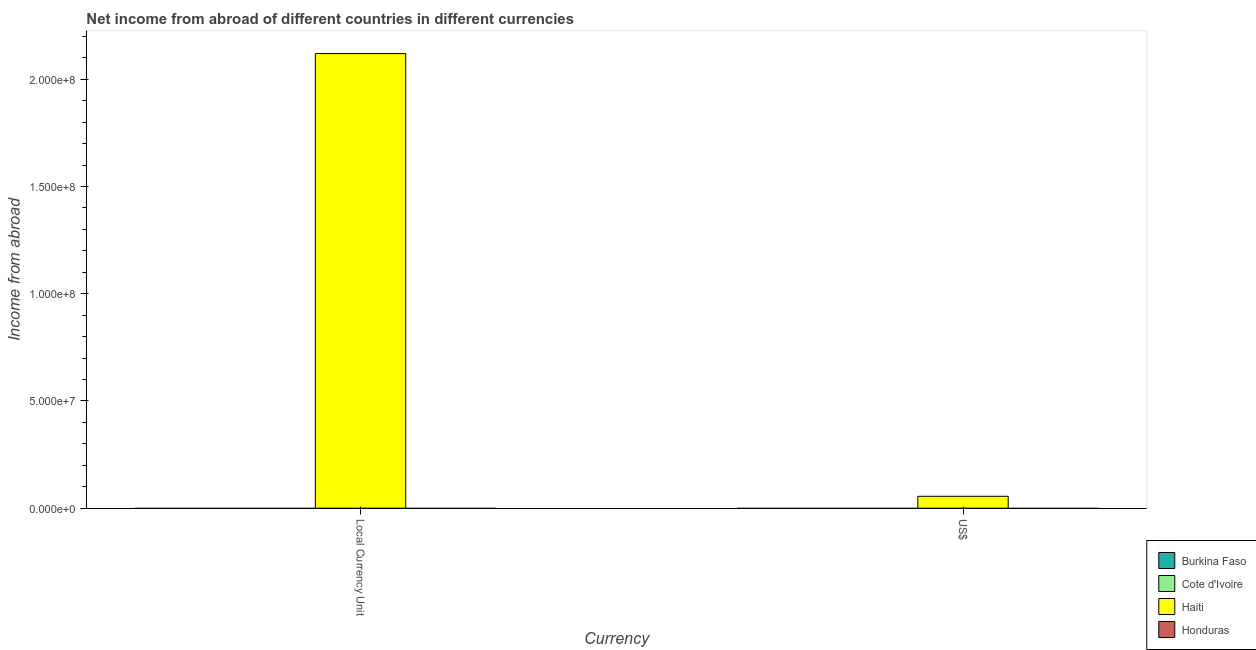How many different coloured bars are there?
Ensure brevity in your answer.  1. Are the number of bars per tick equal to the number of legend labels?
Keep it short and to the point. No. How many bars are there on the 1st tick from the left?
Ensure brevity in your answer.  1. How many bars are there on the 1st tick from the right?
Your answer should be compact. 1. What is the label of the 1st group of bars from the left?
Make the answer very short. Local Currency Unit. What is the income from abroad in constant 2005 us$ in Cote d'Ivoire?
Keep it short and to the point. 0. Across all countries, what is the maximum income from abroad in us$?
Offer a terse response. 5.54e+06. In which country was the income from abroad in constant 2005 us$ maximum?
Your answer should be compact. Haiti. What is the total income from abroad in us$ in the graph?
Ensure brevity in your answer.  5.54e+06. What is the average income from abroad in constant 2005 us$ per country?
Ensure brevity in your answer.  5.30e+07. What is the difference between the income from abroad in constant 2005 us$ and income from abroad in us$ in Haiti?
Provide a succinct answer. 2.06e+08. In how many countries, is the income from abroad in constant 2005 us$ greater than the average income from abroad in constant 2005 us$ taken over all countries?
Offer a very short reply. 1. What is the difference between two consecutive major ticks on the Y-axis?
Provide a succinct answer. 5.00e+07. Does the graph contain grids?
Provide a succinct answer. No. Where does the legend appear in the graph?
Provide a short and direct response. Bottom right. What is the title of the graph?
Offer a terse response. Net income from abroad of different countries in different currencies. Does "Greenland" appear as one of the legend labels in the graph?
Your answer should be very brief. No. What is the label or title of the X-axis?
Make the answer very short. Currency. What is the label or title of the Y-axis?
Ensure brevity in your answer.  Income from abroad. What is the Income from abroad in Burkina Faso in Local Currency Unit?
Provide a short and direct response. 0. What is the Income from abroad of Haiti in Local Currency Unit?
Your answer should be compact. 2.12e+08. What is the Income from abroad in Honduras in Local Currency Unit?
Offer a very short reply. 0. What is the Income from abroad in Burkina Faso in US$?
Offer a very short reply. 0. What is the Income from abroad in Cote d'Ivoire in US$?
Give a very brief answer. 0. What is the Income from abroad of Haiti in US$?
Provide a succinct answer. 5.54e+06. What is the Income from abroad of Honduras in US$?
Your response must be concise. 0. Across all Currency, what is the maximum Income from abroad in Haiti?
Your answer should be very brief. 2.12e+08. Across all Currency, what is the minimum Income from abroad of Haiti?
Keep it short and to the point. 5.54e+06. What is the total Income from abroad in Cote d'Ivoire in the graph?
Your response must be concise. 0. What is the total Income from abroad of Haiti in the graph?
Give a very brief answer. 2.18e+08. What is the difference between the Income from abroad in Haiti in Local Currency Unit and that in US$?
Provide a short and direct response. 2.06e+08. What is the average Income from abroad of Burkina Faso per Currency?
Offer a terse response. 0. What is the average Income from abroad of Cote d'Ivoire per Currency?
Provide a short and direct response. 0. What is the average Income from abroad of Haiti per Currency?
Keep it short and to the point. 1.09e+08. What is the average Income from abroad of Honduras per Currency?
Your response must be concise. 0. What is the ratio of the Income from abroad in Haiti in Local Currency Unit to that in US$?
Your response must be concise. 38.27. What is the difference between the highest and the second highest Income from abroad in Haiti?
Your answer should be very brief. 2.06e+08. What is the difference between the highest and the lowest Income from abroad of Haiti?
Provide a short and direct response. 2.06e+08. 